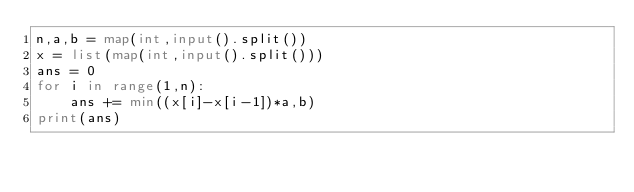Convert code to text. <code><loc_0><loc_0><loc_500><loc_500><_Python_>n,a,b = map(int,input().split())
x = list(map(int,input().split()))
ans = 0
for i in range(1,n):
    ans += min((x[i]-x[i-1])*a,b)
print(ans)</code> 